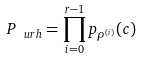Convert formula to latex. <formula><loc_0><loc_0><loc_500><loc_500>P _ { \ u r h } = \prod _ { i = 0 } ^ { r - 1 } p _ { \rho ^ { ( i ) } } ( c )</formula> 